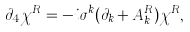Convert formula to latex. <formula><loc_0><loc_0><loc_500><loc_500>\partial _ { 4 } \chi ^ { R } = - i \sigma ^ { k } ( \partial _ { k } + A ^ { R } _ { k } ) \chi ^ { R } ,</formula> 